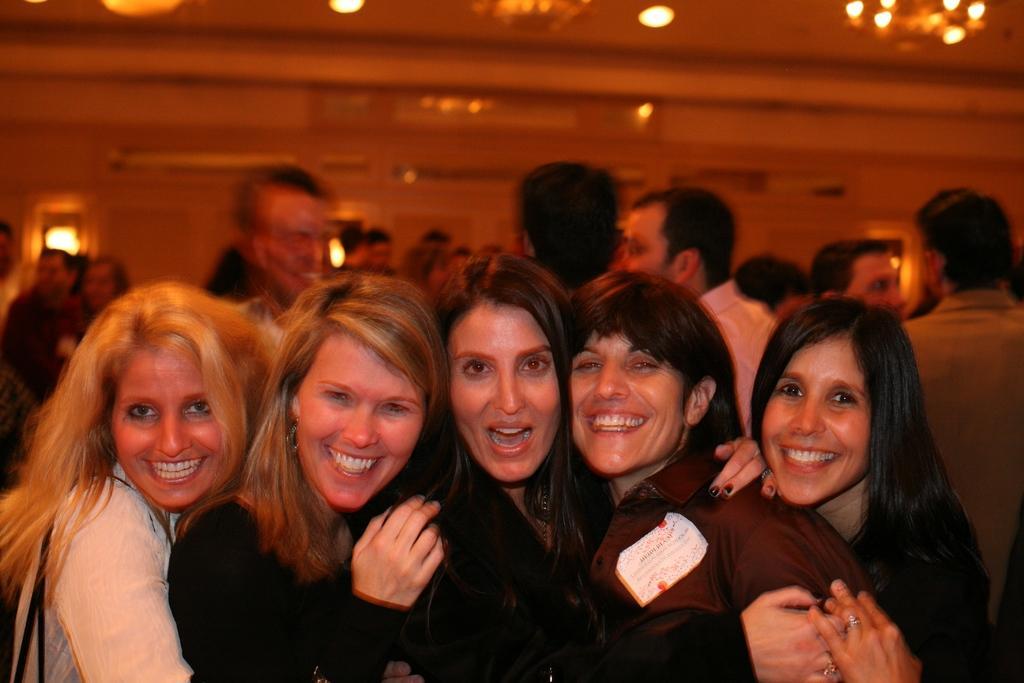Describe this image in one or two sentences. In this image there are five women standing towards the bottom of the image, there is a woman wearing a bag, there are group of persons, there is a wall, there is a roof towards the top of the image, there are lights towards the top of the image. 